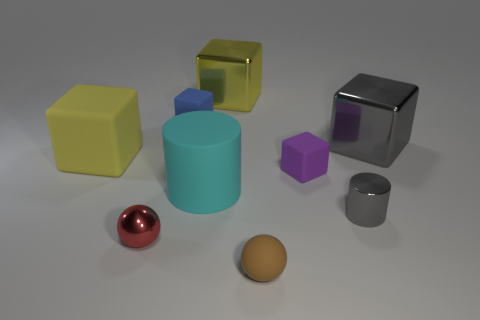Subtract all big yellow matte cubes. How many cubes are left? 4 Add 1 small purple cylinders. How many objects exist? 10 Subtract all spheres. How many objects are left? 7 Subtract all tiny purple blocks. Subtract all tiny blue rubber things. How many objects are left? 7 Add 2 large cyan objects. How many large cyan objects are left? 3 Add 7 tiny cubes. How many tiny cubes exist? 9 Subtract 0 cyan cubes. How many objects are left? 9 